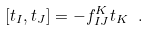<formula> <loc_0><loc_0><loc_500><loc_500>[ t _ { I } , t _ { J } ] = - f _ { I J } ^ { K } t _ { K } \ .</formula> 